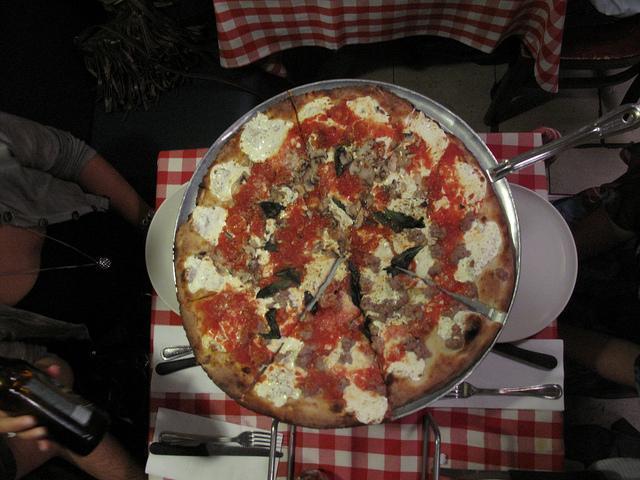Is the caption "The pizza is on the dining table." a true representation of the image?
Answer yes or no. Yes. 